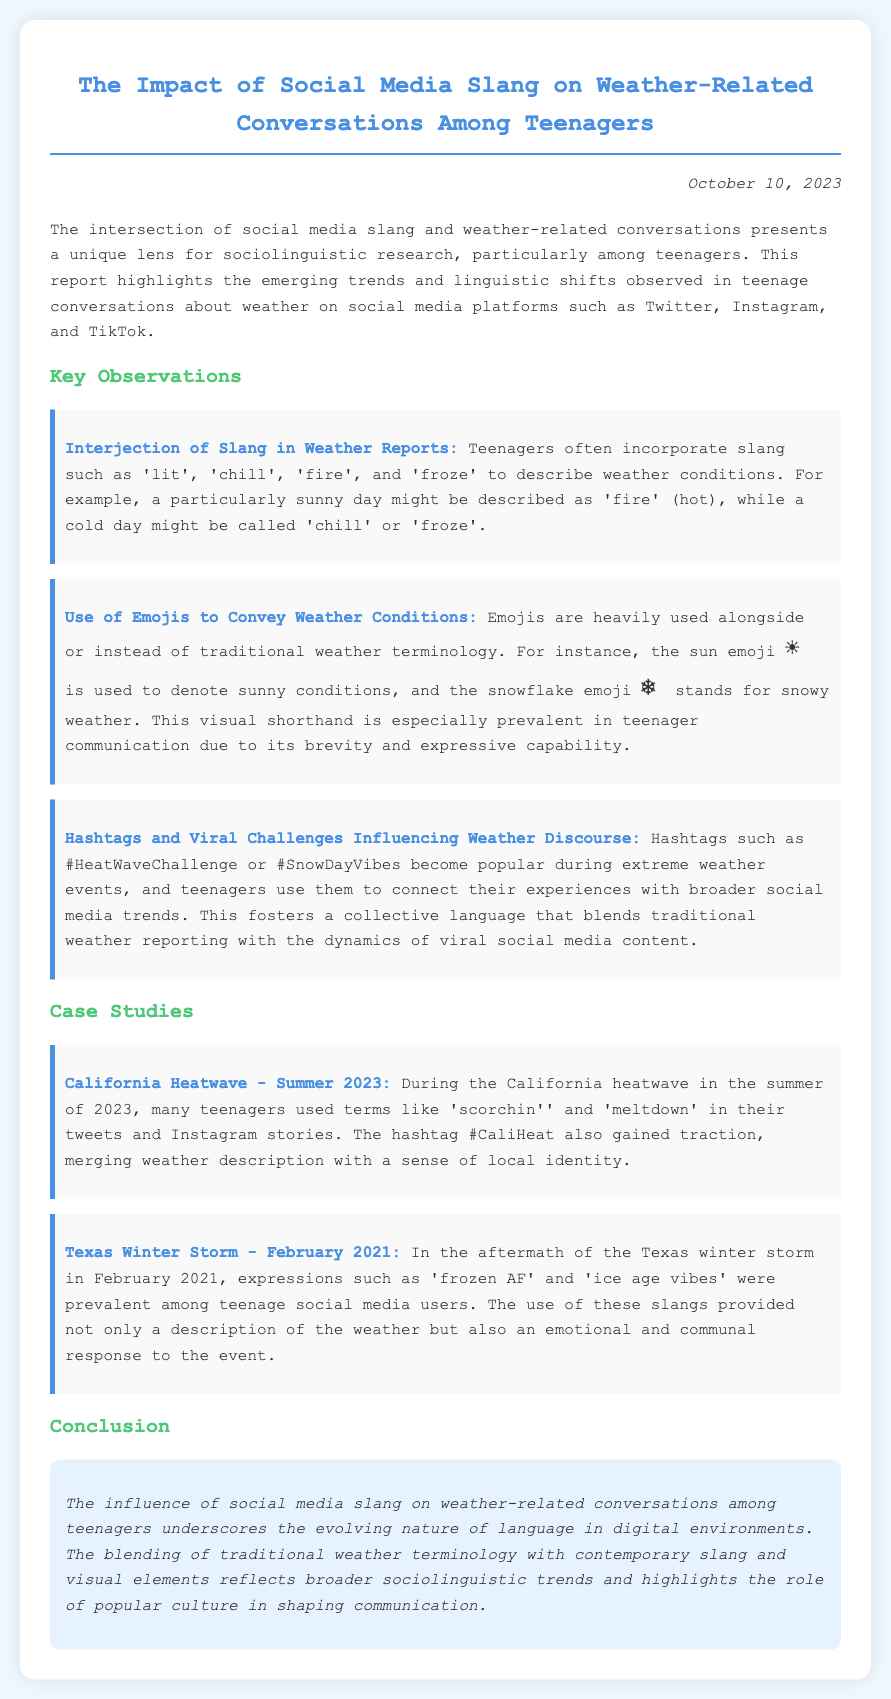What is the title of the report? The title of the report provides key insight into the document's focus on the impact of slang on weather conversations among teenagers.
Answer: The Impact of Social Media Slang on Weather-Related Conversations Among Teenagers When was the report published? The publication date is noted in the document and is significant in contextualizing the data presented.
Answer: October 10, 2023 What slang terms are mentioned for describing hot weather? The slang terms provide examples of how teenagers might express weather conditions creatively through language.
Answer: fire What emoji is used to denote sunny conditions? The emoji represents a popular visual element used by teenagers to express weather conditions succinctly.
Answer: ☀️ What hashtag became popular during the California heatwave? The hashtag indicates how social media trends can intersect with weather events, showcasing collective teenage responses.
Answer: #CaliHeat Which expression was prevalent among teens during the Texas winter storm? This expression reflects emotional responses and cultural references associated with extreme weather experiences.
Answer: frozen AF What year did the Texas winter storm occur? The year is crucial for contextualizing the referenced events and understanding the timeline of weather-related slang development.
Answer: February 2021 What is used alongside or instead of traditional weather terminology? This aspect highlights the modern adaptations in communication among teenagers when discussing weather.
Answer: Emojis What significant trend does the report discuss in relation to weather discourse? The trend encapsulates the blending of social media vernacular with weather terminology among teenagers.
Answer: Viral Challenges 